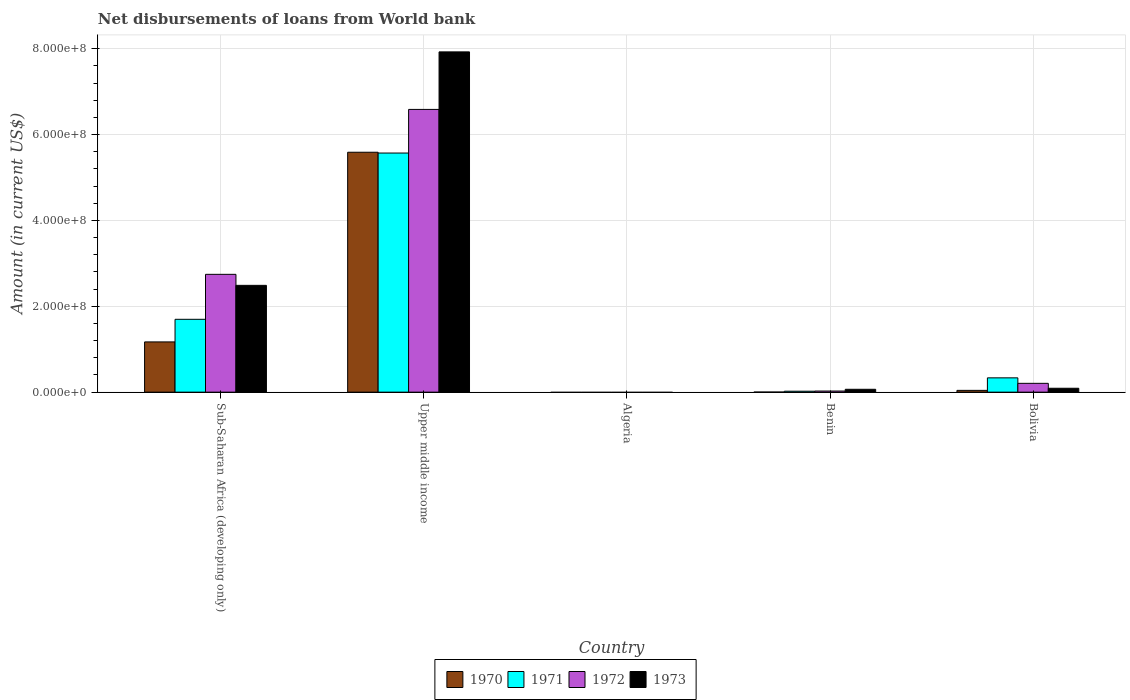How many different coloured bars are there?
Your answer should be very brief. 4. How many bars are there on the 5th tick from the right?
Provide a succinct answer. 4. What is the label of the 2nd group of bars from the left?
Offer a very short reply. Upper middle income. In how many cases, is the number of bars for a given country not equal to the number of legend labels?
Offer a very short reply. 1. What is the amount of loan disbursed from World Bank in 1971 in Bolivia?
Your answer should be very brief. 3.33e+07. Across all countries, what is the maximum amount of loan disbursed from World Bank in 1972?
Keep it short and to the point. 6.59e+08. In which country was the amount of loan disbursed from World Bank in 1970 maximum?
Your answer should be compact. Upper middle income. What is the total amount of loan disbursed from World Bank in 1972 in the graph?
Provide a short and direct response. 9.56e+08. What is the difference between the amount of loan disbursed from World Bank in 1971 in Benin and that in Bolivia?
Your answer should be compact. -3.11e+07. What is the difference between the amount of loan disbursed from World Bank in 1973 in Bolivia and the amount of loan disbursed from World Bank in 1972 in Upper middle income?
Offer a terse response. -6.50e+08. What is the average amount of loan disbursed from World Bank in 1971 per country?
Your answer should be very brief. 1.52e+08. What is the difference between the amount of loan disbursed from World Bank of/in 1973 and amount of loan disbursed from World Bank of/in 1971 in Upper middle income?
Offer a very short reply. 2.36e+08. In how many countries, is the amount of loan disbursed from World Bank in 1973 greater than 600000000 US$?
Keep it short and to the point. 1. What is the ratio of the amount of loan disbursed from World Bank in 1971 in Benin to that in Bolivia?
Offer a terse response. 0.07. Is the amount of loan disbursed from World Bank in 1973 in Bolivia less than that in Sub-Saharan Africa (developing only)?
Your response must be concise. Yes. Is the difference between the amount of loan disbursed from World Bank in 1973 in Benin and Bolivia greater than the difference between the amount of loan disbursed from World Bank in 1971 in Benin and Bolivia?
Provide a succinct answer. Yes. What is the difference between the highest and the second highest amount of loan disbursed from World Bank in 1970?
Keep it short and to the point. 5.55e+08. What is the difference between the highest and the lowest amount of loan disbursed from World Bank in 1972?
Give a very brief answer. 6.59e+08. Is the sum of the amount of loan disbursed from World Bank in 1973 in Benin and Upper middle income greater than the maximum amount of loan disbursed from World Bank in 1972 across all countries?
Give a very brief answer. Yes. Is it the case that in every country, the sum of the amount of loan disbursed from World Bank in 1970 and amount of loan disbursed from World Bank in 1972 is greater than the sum of amount of loan disbursed from World Bank in 1971 and amount of loan disbursed from World Bank in 1973?
Keep it short and to the point. No. Is it the case that in every country, the sum of the amount of loan disbursed from World Bank in 1972 and amount of loan disbursed from World Bank in 1973 is greater than the amount of loan disbursed from World Bank in 1971?
Make the answer very short. No. How many bars are there?
Ensure brevity in your answer.  16. How many countries are there in the graph?
Ensure brevity in your answer.  5. What is the difference between two consecutive major ticks on the Y-axis?
Your response must be concise. 2.00e+08. Are the values on the major ticks of Y-axis written in scientific E-notation?
Give a very brief answer. Yes. Does the graph contain any zero values?
Keep it short and to the point. Yes. Where does the legend appear in the graph?
Give a very brief answer. Bottom center. How many legend labels are there?
Your answer should be compact. 4. How are the legend labels stacked?
Keep it short and to the point. Horizontal. What is the title of the graph?
Your answer should be very brief. Net disbursements of loans from World bank. Does "1982" appear as one of the legend labels in the graph?
Offer a very short reply. No. What is the Amount (in current US$) in 1970 in Sub-Saharan Africa (developing only)?
Your response must be concise. 1.17e+08. What is the Amount (in current US$) in 1971 in Sub-Saharan Africa (developing only)?
Your answer should be compact. 1.70e+08. What is the Amount (in current US$) in 1972 in Sub-Saharan Africa (developing only)?
Ensure brevity in your answer.  2.74e+08. What is the Amount (in current US$) in 1973 in Sub-Saharan Africa (developing only)?
Your answer should be compact. 2.49e+08. What is the Amount (in current US$) in 1970 in Upper middle income?
Make the answer very short. 5.59e+08. What is the Amount (in current US$) of 1971 in Upper middle income?
Your response must be concise. 5.57e+08. What is the Amount (in current US$) in 1972 in Upper middle income?
Provide a short and direct response. 6.59e+08. What is the Amount (in current US$) in 1973 in Upper middle income?
Make the answer very short. 7.93e+08. What is the Amount (in current US$) of 1970 in Algeria?
Your answer should be very brief. 0. What is the Amount (in current US$) in 1972 in Algeria?
Provide a succinct answer. 0. What is the Amount (in current US$) in 1973 in Algeria?
Give a very brief answer. 0. What is the Amount (in current US$) of 1970 in Benin?
Provide a succinct answer. 1.45e+05. What is the Amount (in current US$) of 1971 in Benin?
Keep it short and to the point. 2.19e+06. What is the Amount (in current US$) in 1972 in Benin?
Ensure brevity in your answer.  2.58e+06. What is the Amount (in current US$) of 1973 in Benin?
Give a very brief answer. 6.67e+06. What is the Amount (in current US$) in 1970 in Bolivia?
Your answer should be very brief. 4.15e+06. What is the Amount (in current US$) in 1971 in Bolivia?
Your answer should be very brief. 3.33e+07. What is the Amount (in current US$) of 1972 in Bolivia?
Your answer should be very brief. 2.05e+07. What is the Amount (in current US$) of 1973 in Bolivia?
Make the answer very short. 9.07e+06. Across all countries, what is the maximum Amount (in current US$) in 1970?
Ensure brevity in your answer.  5.59e+08. Across all countries, what is the maximum Amount (in current US$) of 1971?
Provide a short and direct response. 5.57e+08. Across all countries, what is the maximum Amount (in current US$) in 1972?
Your answer should be very brief. 6.59e+08. Across all countries, what is the maximum Amount (in current US$) in 1973?
Your answer should be very brief. 7.93e+08. Across all countries, what is the minimum Amount (in current US$) in 1970?
Your answer should be very brief. 0. What is the total Amount (in current US$) of 1970 in the graph?
Provide a short and direct response. 6.80e+08. What is the total Amount (in current US$) in 1971 in the graph?
Give a very brief answer. 7.62e+08. What is the total Amount (in current US$) in 1972 in the graph?
Your answer should be very brief. 9.56e+08. What is the total Amount (in current US$) in 1973 in the graph?
Offer a terse response. 1.06e+09. What is the difference between the Amount (in current US$) in 1970 in Sub-Saharan Africa (developing only) and that in Upper middle income?
Offer a terse response. -4.42e+08. What is the difference between the Amount (in current US$) in 1971 in Sub-Saharan Africa (developing only) and that in Upper middle income?
Give a very brief answer. -3.87e+08. What is the difference between the Amount (in current US$) in 1972 in Sub-Saharan Africa (developing only) and that in Upper middle income?
Give a very brief answer. -3.84e+08. What is the difference between the Amount (in current US$) of 1973 in Sub-Saharan Africa (developing only) and that in Upper middle income?
Keep it short and to the point. -5.44e+08. What is the difference between the Amount (in current US$) of 1970 in Sub-Saharan Africa (developing only) and that in Benin?
Your answer should be compact. 1.17e+08. What is the difference between the Amount (in current US$) in 1971 in Sub-Saharan Africa (developing only) and that in Benin?
Your answer should be very brief. 1.68e+08. What is the difference between the Amount (in current US$) in 1972 in Sub-Saharan Africa (developing only) and that in Benin?
Give a very brief answer. 2.72e+08. What is the difference between the Amount (in current US$) in 1973 in Sub-Saharan Africa (developing only) and that in Benin?
Make the answer very short. 2.42e+08. What is the difference between the Amount (in current US$) of 1970 in Sub-Saharan Africa (developing only) and that in Bolivia?
Offer a terse response. 1.13e+08. What is the difference between the Amount (in current US$) in 1971 in Sub-Saharan Africa (developing only) and that in Bolivia?
Provide a short and direct response. 1.36e+08. What is the difference between the Amount (in current US$) of 1972 in Sub-Saharan Africa (developing only) and that in Bolivia?
Offer a terse response. 2.54e+08. What is the difference between the Amount (in current US$) of 1973 in Sub-Saharan Africa (developing only) and that in Bolivia?
Offer a terse response. 2.40e+08. What is the difference between the Amount (in current US$) of 1970 in Upper middle income and that in Benin?
Provide a short and direct response. 5.59e+08. What is the difference between the Amount (in current US$) in 1971 in Upper middle income and that in Benin?
Provide a short and direct response. 5.55e+08. What is the difference between the Amount (in current US$) in 1972 in Upper middle income and that in Benin?
Your answer should be compact. 6.56e+08. What is the difference between the Amount (in current US$) of 1973 in Upper middle income and that in Benin?
Provide a short and direct response. 7.86e+08. What is the difference between the Amount (in current US$) of 1970 in Upper middle income and that in Bolivia?
Your answer should be compact. 5.55e+08. What is the difference between the Amount (in current US$) of 1971 in Upper middle income and that in Bolivia?
Keep it short and to the point. 5.24e+08. What is the difference between the Amount (in current US$) of 1972 in Upper middle income and that in Bolivia?
Your answer should be compact. 6.38e+08. What is the difference between the Amount (in current US$) in 1973 in Upper middle income and that in Bolivia?
Offer a terse response. 7.84e+08. What is the difference between the Amount (in current US$) in 1970 in Benin and that in Bolivia?
Make the answer very short. -4.00e+06. What is the difference between the Amount (in current US$) of 1971 in Benin and that in Bolivia?
Make the answer very short. -3.11e+07. What is the difference between the Amount (in current US$) of 1972 in Benin and that in Bolivia?
Offer a terse response. -1.79e+07. What is the difference between the Amount (in current US$) of 1973 in Benin and that in Bolivia?
Your answer should be very brief. -2.40e+06. What is the difference between the Amount (in current US$) of 1970 in Sub-Saharan Africa (developing only) and the Amount (in current US$) of 1971 in Upper middle income?
Keep it short and to the point. -4.40e+08. What is the difference between the Amount (in current US$) in 1970 in Sub-Saharan Africa (developing only) and the Amount (in current US$) in 1972 in Upper middle income?
Keep it short and to the point. -5.42e+08. What is the difference between the Amount (in current US$) in 1970 in Sub-Saharan Africa (developing only) and the Amount (in current US$) in 1973 in Upper middle income?
Your answer should be very brief. -6.76e+08. What is the difference between the Amount (in current US$) in 1971 in Sub-Saharan Africa (developing only) and the Amount (in current US$) in 1972 in Upper middle income?
Make the answer very short. -4.89e+08. What is the difference between the Amount (in current US$) in 1971 in Sub-Saharan Africa (developing only) and the Amount (in current US$) in 1973 in Upper middle income?
Your response must be concise. -6.23e+08. What is the difference between the Amount (in current US$) of 1972 in Sub-Saharan Africa (developing only) and the Amount (in current US$) of 1973 in Upper middle income?
Keep it short and to the point. -5.18e+08. What is the difference between the Amount (in current US$) in 1970 in Sub-Saharan Africa (developing only) and the Amount (in current US$) in 1971 in Benin?
Provide a short and direct response. 1.15e+08. What is the difference between the Amount (in current US$) in 1970 in Sub-Saharan Africa (developing only) and the Amount (in current US$) in 1972 in Benin?
Offer a terse response. 1.14e+08. What is the difference between the Amount (in current US$) of 1970 in Sub-Saharan Africa (developing only) and the Amount (in current US$) of 1973 in Benin?
Your answer should be compact. 1.10e+08. What is the difference between the Amount (in current US$) of 1971 in Sub-Saharan Africa (developing only) and the Amount (in current US$) of 1972 in Benin?
Provide a succinct answer. 1.67e+08. What is the difference between the Amount (in current US$) in 1971 in Sub-Saharan Africa (developing only) and the Amount (in current US$) in 1973 in Benin?
Offer a very short reply. 1.63e+08. What is the difference between the Amount (in current US$) in 1972 in Sub-Saharan Africa (developing only) and the Amount (in current US$) in 1973 in Benin?
Provide a short and direct response. 2.68e+08. What is the difference between the Amount (in current US$) in 1970 in Sub-Saharan Africa (developing only) and the Amount (in current US$) in 1971 in Bolivia?
Your answer should be compact. 8.37e+07. What is the difference between the Amount (in current US$) of 1970 in Sub-Saharan Africa (developing only) and the Amount (in current US$) of 1972 in Bolivia?
Your answer should be compact. 9.65e+07. What is the difference between the Amount (in current US$) of 1970 in Sub-Saharan Africa (developing only) and the Amount (in current US$) of 1973 in Bolivia?
Your answer should be compact. 1.08e+08. What is the difference between the Amount (in current US$) of 1971 in Sub-Saharan Africa (developing only) and the Amount (in current US$) of 1972 in Bolivia?
Give a very brief answer. 1.49e+08. What is the difference between the Amount (in current US$) of 1971 in Sub-Saharan Africa (developing only) and the Amount (in current US$) of 1973 in Bolivia?
Your answer should be compact. 1.61e+08. What is the difference between the Amount (in current US$) of 1972 in Sub-Saharan Africa (developing only) and the Amount (in current US$) of 1973 in Bolivia?
Your answer should be compact. 2.65e+08. What is the difference between the Amount (in current US$) of 1970 in Upper middle income and the Amount (in current US$) of 1971 in Benin?
Your response must be concise. 5.57e+08. What is the difference between the Amount (in current US$) of 1970 in Upper middle income and the Amount (in current US$) of 1972 in Benin?
Keep it short and to the point. 5.56e+08. What is the difference between the Amount (in current US$) in 1970 in Upper middle income and the Amount (in current US$) in 1973 in Benin?
Keep it short and to the point. 5.52e+08. What is the difference between the Amount (in current US$) of 1971 in Upper middle income and the Amount (in current US$) of 1972 in Benin?
Provide a short and direct response. 5.55e+08. What is the difference between the Amount (in current US$) in 1971 in Upper middle income and the Amount (in current US$) in 1973 in Benin?
Your response must be concise. 5.50e+08. What is the difference between the Amount (in current US$) of 1972 in Upper middle income and the Amount (in current US$) of 1973 in Benin?
Keep it short and to the point. 6.52e+08. What is the difference between the Amount (in current US$) in 1970 in Upper middle income and the Amount (in current US$) in 1971 in Bolivia?
Your response must be concise. 5.26e+08. What is the difference between the Amount (in current US$) in 1970 in Upper middle income and the Amount (in current US$) in 1972 in Bolivia?
Make the answer very short. 5.38e+08. What is the difference between the Amount (in current US$) in 1970 in Upper middle income and the Amount (in current US$) in 1973 in Bolivia?
Offer a terse response. 5.50e+08. What is the difference between the Amount (in current US$) of 1971 in Upper middle income and the Amount (in current US$) of 1972 in Bolivia?
Your response must be concise. 5.37e+08. What is the difference between the Amount (in current US$) of 1971 in Upper middle income and the Amount (in current US$) of 1973 in Bolivia?
Make the answer very short. 5.48e+08. What is the difference between the Amount (in current US$) in 1972 in Upper middle income and the Amount (in current US$) in 1973 in Bolivia?
Make the answer very short. 6.50e+08. What is the difference between the Amount (in current US$) of 1970 in Benin and the Amount (in current US$) of 1971 in Bolivia?
Offer a very short reply. -3.32e+07. What is the difference between the Amount (in current US$) of 1970 in Benin and the Amount (in current US$) of 1972 in Bolivia?
Offer a terse response. -2.04e+07. What is the difference between the Amount (in current US$) in 1970 in Benin and the Amount (in current US$) in 1973 in Bolivia?
Keep it short and to the point. -8.92e+06. What is the difference between the Amount (in current US$) of 1971 in Benin and the Amount (in current US$) of 1972 in Bolivia?
Provide a succinct answer. -1.83e+07. What is the difference between the Amount (in current US$) in 1971 in Benin and the Amount (in current US$) in 1973 in Bolivia?
Ensure brevity in your answer.  -6.88e+06. What is the difference between the Amount (in current US$) in 1972 in Benin and the Amount (in current US$) in 1973 in Bolivia?
Offer a terse response. -6.49e+06. What is the average Amount (in current US$) of 1970 per country?
Your answer should be compact. 1.36e+08. What is the average Amount (in current US$) in 1971 per country?
Offer a terse response. 1.52e+08. What is the average Amount (in current US$) in 1972 per country?
Make the answer very short. 1.91e+08. What is the average Amount (in current US$) of 1973 per country?
Offer a terse response. 2.11e+08. What is the difference between the Amount (in current US$) of 1970 and Amount (in current US$) of 1971 in Sub-Saharan Africa (developing only)?
Your answer should be very brief. -5.27e+07. What is the difference between the Amount (in current US$) of 1970 and Amount (in current US$) of 1972 in Sub-Saharan Africa (developing only)?
Offer a terse response. -1.57e+08. What is the difference between the Amount (in current US$) in 1970 and Amount (in current US$) in 1973 in Sub-Saharan Africa (developing only)?
Your response must be concise. -1.32e+08. What is the difference between the Amount (in current US$) of 1971 and Amount (in current US$) of 1972 in Sub-Saharan Africa (developing only)?
Provide a succinct answer. -1.05e+08. What is the difference between the Amount (in current US$) in 1971 and Amount (in current US$) in 1973 in Sub-Saharan Africa (developing only)?
Offer a terse response. -7.91e+07. What is the difference between the Amount (in current US$) in 1972 and Amount (in current US$) in 1973 in Sub-Saharan Africa (developing only)?
Offer a terse response. 2.57e+07. What is the difference between the Amount (in current US$) of 1970 and Amount (in current US$) of 1971 in Upper middle income?
Your answer should be compact. 1.84e+06. What is the difference between the Amount (in current US$) in 1970 and Amount (in current US$) in 1972 in Upper middle income?
Offer a very short reply. -9.98e+07. What is the difference between the Amount (in current US$) of 1970 and Amount (in current US$) of 1973 in Upper middle income?
Make the answer very short. -2.34e+08. What is the difference between the Amount (in current US$) in 1971 and Amount (in current US$) in 1972 in Upper middle income?
Your answer should be very brief. -1.02e+08. What is the difference between the Amount (in current US$) in 1971 and Amount (in current US$) in 1973 in Upper middle income?
Provide a succinct answer. -2.36e+08. What is the difference between the Amount (in current US$) in 1972 and Amount (in current US$) in 1973 in Upper middle income?
Provide a succinct answer. -1.34e+08. What is the difference between the Amount (in current US$) in 1970 and Amount (in current US$) in 1971 in Benin?
Make the answer very short. -2.04e+06. What is the difference between the Amount (in current US$) in 1970 and Amount (in current US$) in 1972 in Benin?
Provide a short and direct response. -2.43e+06. What is the difference between the Amount (in current US$) of 1970 and Amount (in current US$) of 1973 in Benin?
Make the answer very short. -6.53e+06. What is the difference between the Amount (in current US$) of 1971 and Amount (in current US$) of 1972 in Benin?
Provide a short and direct response. -3.92e+05. What is the difference between the Amount (in current US$) of 1971 and Amount (in current US$) of 1973 in Benin?
Offer a terse response. -4.49e+06. What is the difference between the Amount (in current US$) in 1972 and Amount (in current US$) in 1973 in Benin?
Your answer should be very brief. -4.09e+06. What is the difference between the Amount (in current US$) in 1970 and Amount (in current US$) in 1971 in Bolivia?
Your response must be concise. -2.92e+07. What is the difference between the Amount (in current US$) in 1970 and Amount (in current US$) in 1972 in Bolivia?
Your response must be concise. -1.64e+07. What is the difference between the Amount (in current US$) of 1970 and Amount (in current US$) of 1973 in Bolivia?
Your answer should be compact. -4.92e+06. What is the difference between the Amount (in current US$) in 1971 and Amount (in current US$) in 1972 in Bolivia?
Ensure brevity in your answer.  1.28e+07. What is the difference between the Amount (in current US$) in 1971 and Amount (in current US$) in 1973 in Bolivia?
Your answer should be compact. 2.42e+07. What is the difference between the Amount (in current US$) in 1972 and Amount (in current US$) in 1973 in Bolivia?
Offer a very short reply. 1.14e+07. What is the ratio of the Amount (in current US$) in 1970 in Sub-Saharan Africa (developing only) to that in Upper middle income?
Offer a terse response. 0.21. What is the ratio of the Amount (in current US$) in 1971 in Sub-Saharan Africa (developing only) to that in Upper middle income?
Ensure brevity in your answer.  0.3. What is the ratio of the Amount (in current US$) in 1972 in Sub-Saharan Africa (developing only) to that in Upper middle income?
Give a very brief answer. 0.42. What is the ratio of the Amount (in current US$) in 1973 in Sub-Saharan Africa (developing only) to that in Upper middle income?
Make the answer very short. 0.31. What is the ratio of the Amount (in current US$) of 1970 in Sub-Saharan Africa (developing only) to that in Benin?
Provide a succinct answer. 807.17. What is the ratio of the Amount (in current US$) in 1971 in Sub-Saharan Africa (developing only) to that in Benin?
Provide a short and direct response. 77.64. What is the ratio of the Amount (in current US$) of 1972 in Sub-Saharan Africa (developing only) to that in Benin?
Your response must be concise. 106.47. What is the ratio of the Amount (in current US$) in 1973 in Sub-Saharan Africa (developing only) to that in Benin?
Provide a short and direct response. 37.29. What is the ratio of the Amount (in current US$) of 1970 in Sub-Saharan Africa (developing only) to that in Bolivia?
Offer a very short reply. 28.21. What is the ratio of the Amount (in current US$) of 1971 in Sub-Saharan Africa (developing only) to that in Bolivia?
Your answer should be compact. 5.1. What is the ratio of the Amount (in current US$) in 1972 in Sub-Saharan Africa (developing only) to that in Bolivia?
Provide a succinct answer. 13.38. What is the ratio of the Amount (in current US$) of 1973 in Sub-Saharan Africa (developing only) to that in Bolivia?
Keep it short and to the point. 27.44. What is the ratio of the Amount (in current US$) in 1970 in Upper middle income to that in Benin?
Give a very brief answer. 3854.79. What is the ratio of the Amount (in current US$) of 1971 in Upper middle income to that in Benin?
Your answer should be compact. 254.85. What is the ratio of the Amount (in current US$) in 1972 in Upper middle income to that in Benin?
Offer a very short reply. 255.52. What is the ratio of the Amount (in current US$) in 1973 in Upper middle income to that in Benin?
Offer a terse response. 118.82. What is the ratio of the Amount (in current US$) of 1970 in Upper middle income to that in Bolivia?
Keep it short and to the point. 134.72. What is the ratio of the Amount (in current US$) in 1971 in Upper middle income to that in Bolivia?
Offer a very short reply. 16.73. What is the ratio of the Amount (in current US$) in 1972 in Upper middle income to that in Bolivia?
Make the answer very short. 32.1. What is the ratio of the Amount (in current US$) of 1973 in Upper middle income to that in Bolivia?
Keep it short and to the point. 87.41. What is the ratio of the Amount (in current US$) in 1970 in Benin to that in Bolivia?
Provide a succinct answer. 0.03. What is the ratio of the Amount (in current US$) in 1971 in Benin to that in Bolivia?
Your answer should be very brief. 0.07. What is the ratio of the Amount (in current US$) of 1972 in Benin to that in Bolivia?
Provide a short and direct response. 0.13. What is the ratio of the Amount (in current US$) of 1973 in Benin to that in Bolivia?
Provide a succinct answer. 0.74. What is the difference between the highest and the second highest Amount (in current US$) in 1970?
Your answer should be very brief. 4.42e+08. What is the difference between the highest and the second highest Amount (in current US$) in 1971?
Offer a very short reply. 3.87e+08. What is the difference between the highest and the second highest Amount (in current US$) of 1972?
Your answer should be compact. 3.84e+08. What is the difference between the highest and the second highest Amount (in current US$) in 1973?
Keep it short and to the point. 5.44e+08. What is the difference between the highest and the lowest Amount (in current US$) in 1970?
Give a very brief answer. 5.59e+08. What is the difference between the highest and the lowest Amount (in current US$) in 1971?
Your answer should be compact. 5.57e+08. What is the difference between the highest and the lowest Amount (in current US$) in 1972?
Provide a succinct answer. 6.59e+08. What is the difference between the highest and the lowest Amount (in current US$) in 1973?
Make the answer very short. 7.93e+08. 